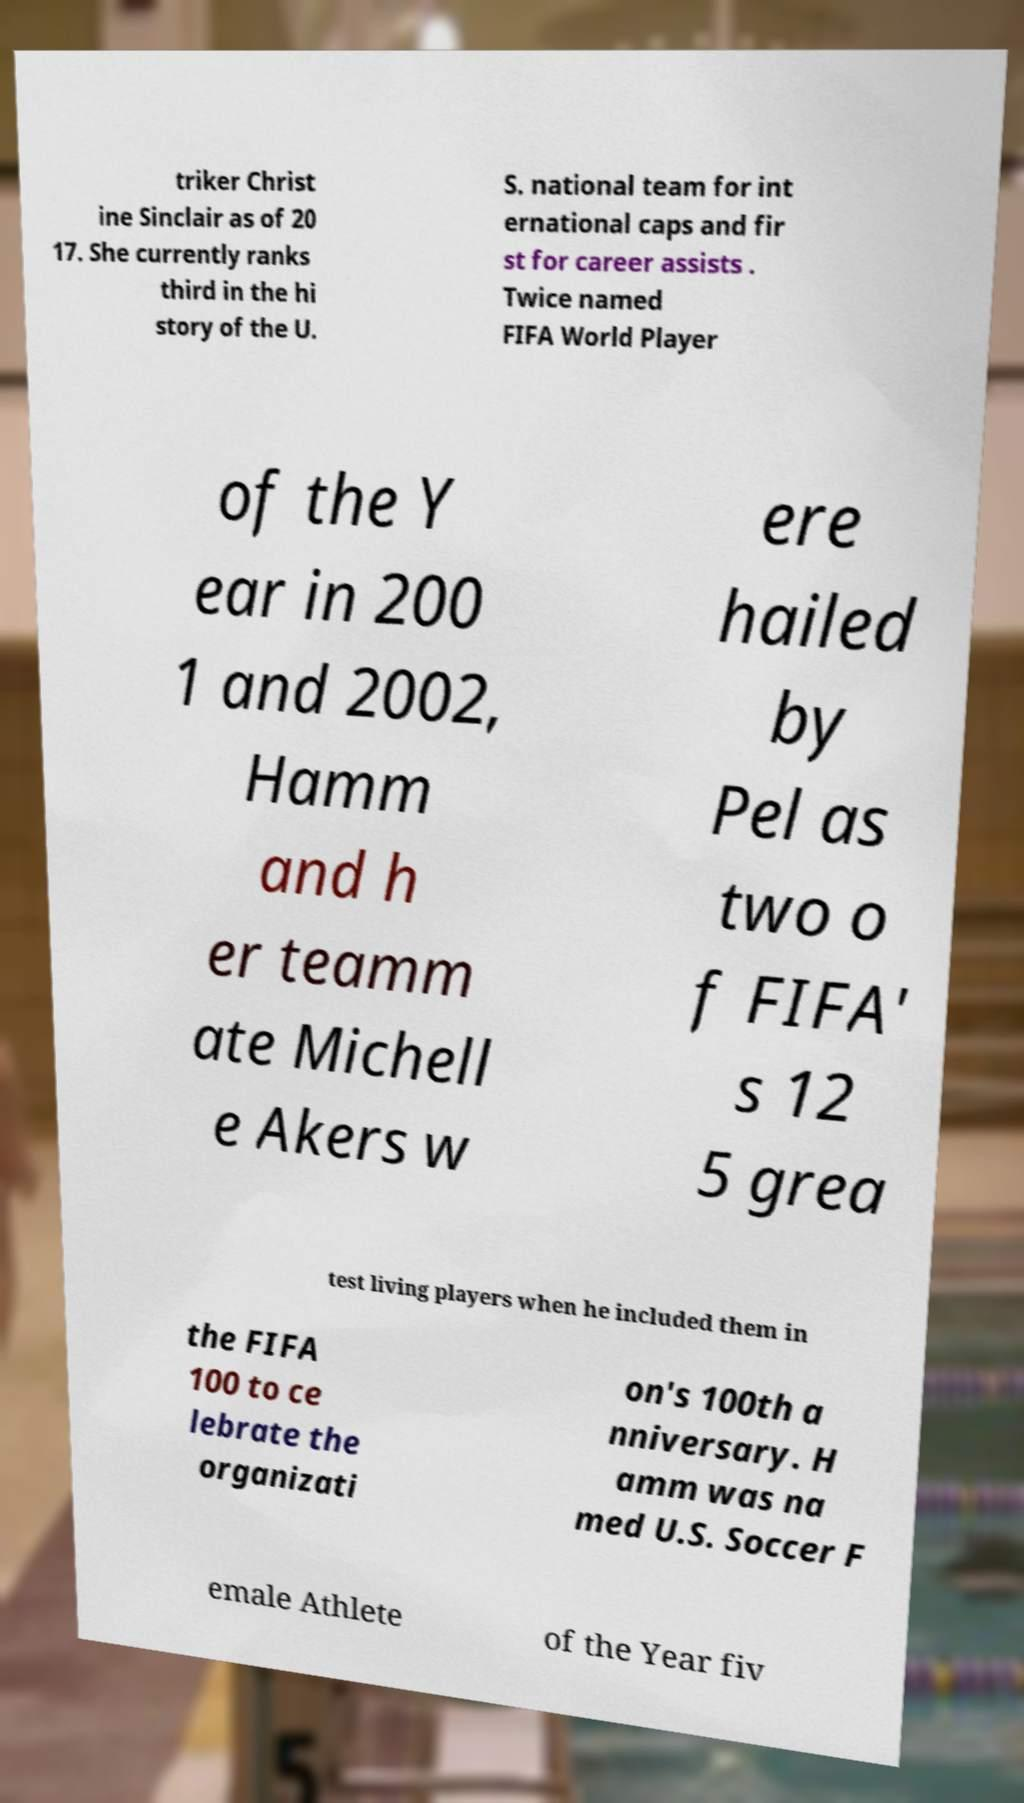Can you accurately transcribe the text from the provided image for me? triker Christ ine Sinclair as of 20 17. She currently ranks third in the hi story of the U. S. national team for int ernational caps and fir st for career assists . Twice named FIFA World Player of the Y ear in 200 1 and 2002, Hamm and h er teamm ate Michell e Akers w ere hailed by Pel as two o f FIFA' s 12 5 grea test living players when he included them in the FIFA 100 to ce lebrate the organizati on's 100th a nniversary. H amm was na med U.S. Soccer F emale Athlete of the Year fiv 